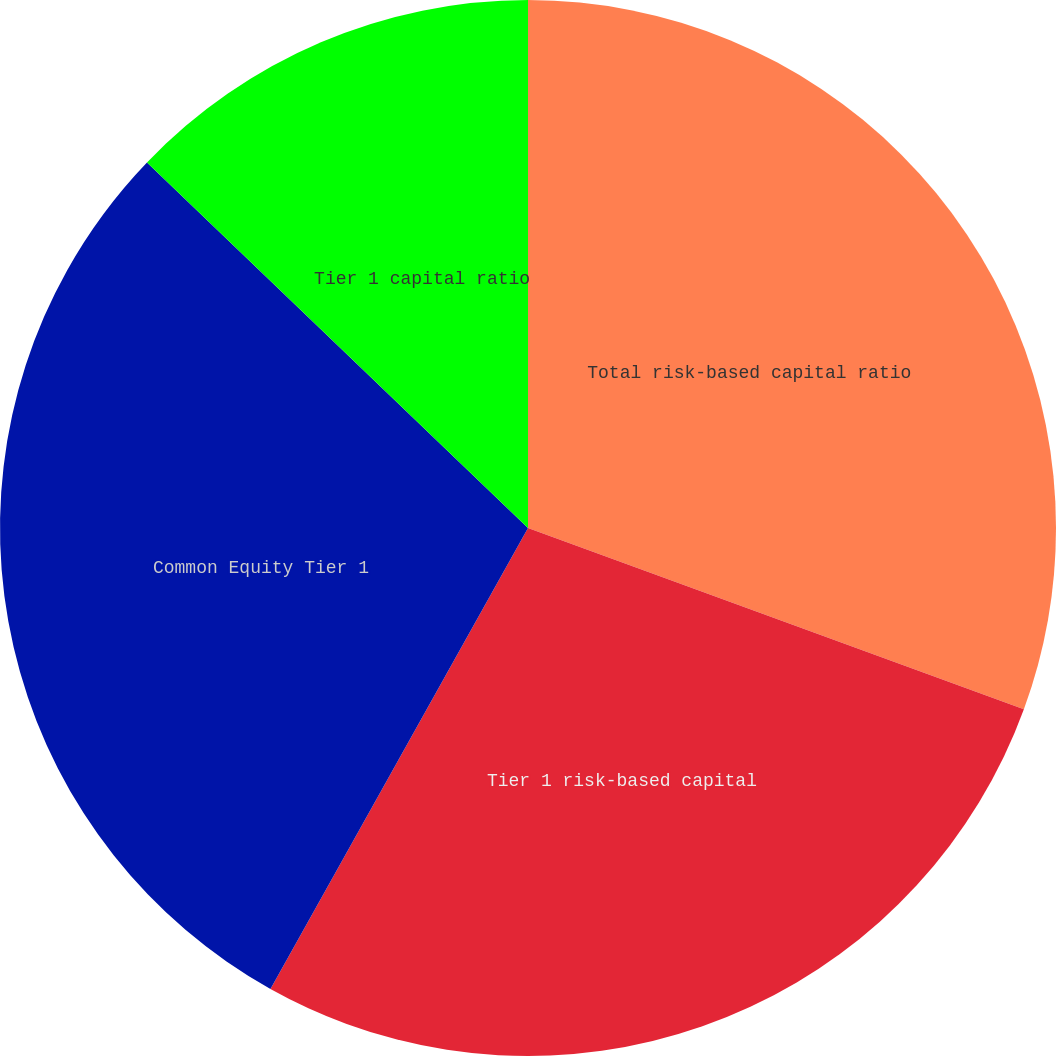<chart> <loc_0><loc_0><loc_500><loc_500><pie_chart><fcel>Total risk-based capital ratio<fcel>Tier 1 risk-based capital<fcel>Common Equity Tier 1<fcel>Tier 1 capital ratio<nl><fcel>30.58%<fcel>27.53%<fcel>29.06%<fcel>12.83%<nl></chart> 